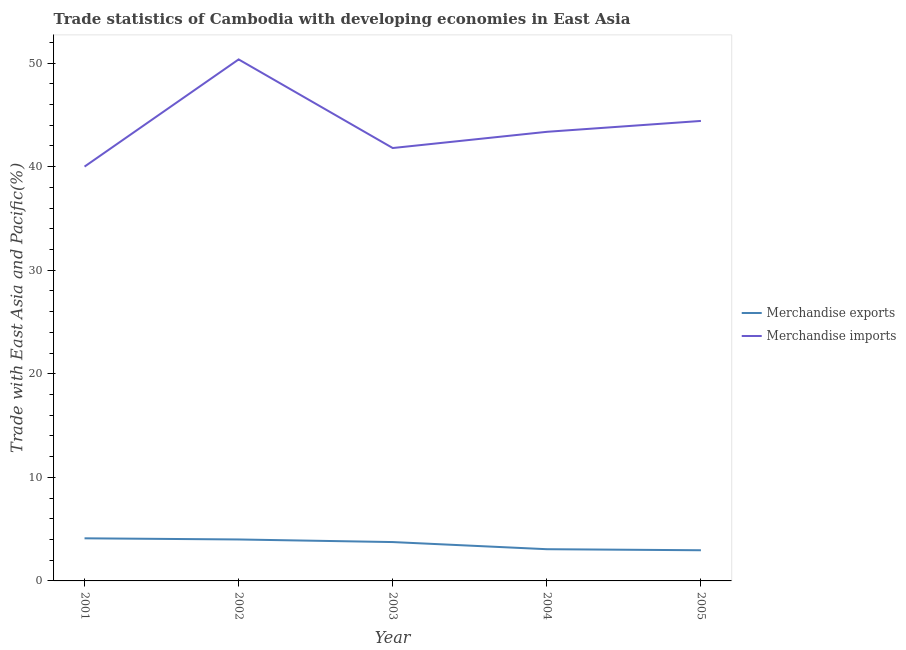How many different coloured lines are there?
Provide a succinct answer. 2. Does the line corresponding to merchandise imports intersect with the line corresponding to merchandise exports?
Ensure brevity in your answer.  No. What is the merchandise exports in 2004?
Provide a short and direct response. 3.06. Across all years, what is the maximum merchandise imports?
Ensure brevity in your answer.  50.36. Across all years, what is the minimum merchandise exports?
Your answer should be very brief. 2.96. In which year was the merchandise exports maximum?
Provide a short and direct response. 2001. In which year was the merchandise exports minimum?
Give a very brief answer. 2005. What is the total merchandise imports in the graph?
Provide a short and direct response. 219.94. What is the difference between the merchandise exports in 2001 and that in 2005?
Provide a short and direct response. 1.15. What is the difference between the merchandise exports in 2003 and the merchandise imports in 2004?
Your response must be concise. -39.61. What is the average merchandise exports per year?
Your response must be concise. 3.58. In the year 2001, what is the difference between the merchandise exports and merchandise imports?
Provide a short and direct response. -35.89. In how many years, is the merchandise exports greater than 46 %?
Offer a terse response. 0. What is the ratio of the merchandise imports in 2001 to that in 2002?
Give a very brief answer. 0.79. Is the difference between the merchandise exports in 2002 and 2003 greater than the difference between the merchandise imports in 2002 and 2003?
Ensure brevity in your answer.  No. What is the difference between the highest and the second highest merchandise imports?
Offer a very short reply. 5.94. What is the difference between the highest and the lowest merchandise imports?
Your response must be concise. 10.35. In how many years, is the merchandise exports greater than the average merchandise exports taken over all years?
Offer a terse response. 3. Does the merchandise imports monotonically increase over the years?
Make the answer very short. No. Is the merchandise exports strictly greater than the merchandise imports over the years?
Keep it short and to the point. No. How many years are there in the graph?
Your answer should be compact. 5. Are the values on the major ticks of Y-axis written in scientific E-notation?
Your answer should be very brief. No. How are the legend labels stacked?
Ensure brevity in your answer.  Vertical. What is the title of the graph?
Your response must be concise. Trade statistics of Cambodia with developing economies in East Asia. What is the label or title of the Y-axis?
Offer a terse response. Trade with East Asia and Pacific(%). What is the Trade with East Asia and Pacific(%) in Merchandise exports in 2001?
Make the answer very short. 4.11. What is the Trade with East Asia and Pacific(%) of Merchandise imports in 2001?
Provide a short and direct response. 40.01. What is the Trade with East Asia and Pacific(%) of Merchandise exports in 2002?
Give a very brief answer. 4. What is the Trade with East Asia and Pacific(%) of Merchandise imports in 2002?
Offer a very short reply. 50.36. What is the Trade with East Asia and Pacific(%) of Merchandise exports in 2003?
Offer a terse response. 3.75. What is the Trade with East Asia and Pacific(%) of Merchandise imports in 2003?
Ensure brevity in your answer.  41.8. What is the Trade with East Asia and Pacific(%) of Merchandise exports in 2004?
Make the answer very short. 3.06. What is the Trade with East Asia and Pacific(%) of Merchandise imports in 2004?
Give a very brief answer. 43.37. What is the Trade with East Asia and Pacific(%) of Merchandise exports in 2005?
Provide a short and direct response. 2.96. What is the Trade with East Asia and Pacific(%) in Merchandise imports in 2005?
Ensure brevity in your answer.  44.42. Across all years, what is the maximum Trade with East Asia and Pacific(%) in Merchandise exports?
Your answer should be compact. 4.11. Across all years, what is the maximum Trade with East Asia and Pacific(%) in Merchandise imports?
Give a very brief answer. 50.36. Across all years, what is the minimum Trade with East Asia and Pacific(%) in Merchandise exports?
Offer a terse response. 2.96. Across all years, what is the minimum Trade with East Asia and Pacific(%) of Merchandise imports?
Provide a succinct answer. 40.01. What is the total Trade with East Asia and Pacific(%) of Merchandise exports in the graph?
Your answer should be compact. 17.89. What is the total Trade with East Asia and Pacific(%) of Merchandise imports in the graph?
Your answer should be compact. 219.94. What is the difference between the Trade with East Asia and Pacific(%) of Merchandise exports in 2001 and that in 2002?
Make the answer very short. 0.11. What is the difference between the Trade with East Asia and Pacific(%) in Merchandise imports in 2001 and that in 2002?
Your answer should be compact. -10.35. What is the difference between the Trade with East Asia and Pacific(%) in Merchandise exports in 2001 and that in 2003?
Offer a terse response. 0.36. What is the difference between the Trade with East Asia and Pacific(%) in Merchandise imports in 2001 and that in 2003?
Offer a terse response. -1.79. What is the difference between the Trade with East Asia and Pacific(%) in Merchandise exports in 2001 and that in 2004?
Your response must be concise. 1.05. What is the difference between the Trade with East Asia and Pacific(%) of Merchandise imports in 2001 and that in 2004?
Offer a very short reply. -3.36. What is the difference between the Trade with East Asia and Pacific(%) of Merchandise exports in 2001 and that in 2005?
Make the answer very short. 1.15. What is the difference between the Trade with East Asia and Pacific(%) in Merchandise imports in 2001 and that in 2005?
Make the answer very short. -4.41. What is the difference between the Trade with East Asia and Pacific(%) in Merchandise exports in 2002 and that in 2003?
Provide a succinct answer. 0.25. What is the difference between the Trade with East Asia and Pacific(%) in Merchandise imports in 2002 and that in 2003?
Give a very brief answer. 8.56. What is the difference between the Trade with East Asia and Pacific(%) in Merchandise exports in 2002 and that in 2004?
Give a very brief answer. 0.94. What is the difference between the Trade with East Asia and Pacific(%) of Merchandise imports in 2002 and that in 2004?
Give a very brief answer. 6.99. What is the difference between the Trade with East Asia and Pacific(%) in Merchandise exports in 2002 and that in 2005?
Offer a terse response. 1.04. What is the difference between the Trade with East Asia and Pacific(%) in Merchandise imports in 2002 and that in 2005?
Ensure brevity in your answer.  5.94. What is the difference between the Trade with East Asia and Pacific(%) in Merchandise exports in 2003 and that in 2004?
Offer a terse response. 0.69. What is the difference between the Trade with East Asia and Pacific(%) of Merchandise imports in 2003 and that in 2004?
Give a very brief answer. -1.56. What is the difference between the Trade with East Asia and Pacific(%) of Merchandise exports in 2003 and that in 2005?
Keep it short and to the point. 0.79. What is the difference between the Trade with East Asia and Pacific(%) in Merchandise imports in 2003 and that in 2005?
Your answer should be very brief. -2.62. What is the difference between the Trade with East Asia and Pacific(%) of Merchandise exports in 2004 and that in 2005?
Your answer should be very brief. 0.1. What is the difference between the Trade with East Asia and Pacific(%) of Merchandise imports in 2004 and that in 2005?
Make the answer very short. -1.05. What is the difference between the Trade with East Asia and Pacific(%) in Merchandise exports in 2001 and the Trade with East Asia and Pacific(%) in Merchandise imports in 2002?
Provide a short and direct response. -46.24. What is the difference between the Trade with East Asia and Pacific(%) of Merchandise exports in 2001 and the Trade with East Asia and Pacific(%) of Merchandise imports in 2003?
Ensure brevity in your answer.  -37.69. What is the difference between the Trade with East Asia and Pacific(%) in Merchandise exports in 2001 and the Trade with East Asia and Pacific(%) in Merchandise imports in 2004?
Give a very brief answer. -39.25. What is the difference between the Trade with East Asia and Pacific(%) of Merchandise exports in 2001 and the Trade with East Asia and Pacific(%) of Merchandise imports in 2005?
Your answer should be compact. -40.3. What is the difference between the Trade with East Asia and Pacific(%) of Merchandise exports in 2002 and the Trade with East Asia and Pacific(%) of Merchandise imports in 2003?
Make the answer very short. -37.8. What is the difference between the Trade with East Asia and Pacific(%) in Merchandise exports in 2002 and the Trade with East Asia and Pacific(%) in Merchandise imports in 2004?
Ensure brevity in your answer.  -39.36. What is the difference between the Trade with East Asia and Pacific(%) of Merchandise exports in 2002 and the Trade with East Asia and Pacific(%) of Merchandise imports in 2005?
Keep it short and to the point. -40.41. What is the difference between the Trade with East Asia and Pacific(%) in Merchandise exports in 2003 and the Trade with East Asia and Pacific(%) in Merchandise imports in 2004?
Offer a very short reply. -39.61. What is the difference between the Trade with East Asia and Pacific(%) in Merchandise exports in 2003 and the Trade with East Asia and Pacific(%) in Merchandise imports in 2005?
Your answer should be compact. -40.66. What is the difference between the Trade with East Asia and Pacific(%) of Merchandise exports in 2004 and the Trade with East Asia and Pacific(%) of Merchandise imports in 2005?
Ensure brevity in your answer.  -41.35. What is the average Trade with East Asia and Pacific(%) in Merchandise exports per year?
Ensure brevity in your answer.  3.58. What is the average Trade with East Asia and Pacific(%) in Merchandise imports per year?
Provide a succinct answer. 43.99. In the year 2001, what is the difference between the Trade with East Asia and Pacific(%) of Merchandise exports and Trade with East Asia and Pacific(%) of Merchandise imports?
Your response must be concise. -35.89. In the year 2002, what is the difference between the Trade with East Asia and Pacific(%) of Merchandise exports and Trade with East Asia and Pacific(%) of Merchandise imports?
Keep it short and to the point. -46.35. In the year 2003, what is the difference between the Trade with East Asia and Pacific(%) in Merchandise exports and Trade with East Asia and Pacific(%) in Merchandise imports?
Your response must be concise. -38.05. In the year 2004, what is the difference between the Trade with East Asia and Pacific(%) of Merchandise exports and Trade with East Asia and Pacific(%) of Merchandise imports?
Offer a very short reply. -40.3. In the year 2005, what is the difference between the Trade with East Asia and Pacific(%) in Merchandise exports and Trade with East Asia and Pacific(%) in Merchandise imports?
Keep it short and to the point. -41.45. What is the ratio of the Trade with East Asia and Pacific(%) of Merchandise exports in 2001 to that in 2002?
Make the answer very short. 1.03. What is the ratio of the Trade with East Asia and Pacific(%) of Merchandise imports in 2001 to that in 2002?
Your answer should be compact. 0.79. What is the ratio of the Trade with East Asia and Pacific(%) in Merchandise exports in 2001 to that in 2003?
Keep it short and to the point. 1.1. What is the ratio of the Trade with East Asia and Pacific(%) in Merchandise imports in 2001 to that in 2003?
Provide a succinct answer. 0.96. What is the ratio of the Trade with East Asia and Pacific(%) of Merchandise exports in 2001 to that in 2004?
Your answer should be compact. 1.34. What is the ratio of the Trade with East Asia and Pacific(%) in Merchandise imports in 2001 to that in 2004?
Your answer should be compact. 0.92. What is the ratio of the Trade with East Asia and Pacific(%) of Merchandise exports in 2001 to that in 2005?
Offer a terse response. 1.39. What is the ratio of the Trade with East Asia and Pacific(%) in Merchandise imports in 2001 to that in 2005?
Offer a terse response. 0.9. What is the ratio of the Trade with East Asia and Pacific(%) of Merchandise exports in 2002 to that in 2003?
Your response must be concise. 1.07. What is the ratio of the Trade with East Asia and Pacific(%) in Merchandise imports in 2002 to that in 2003?
Your response must be concise. 1.2. What is the ratio of the Trade with East Asia and Pacific(%) in Merchandise exports in 2002 to that in 2004?
Offer a terse response. 1.31. What is the ratio of the Trade with East Asia and Pacific(%) of Merchandise imports in 2002 to that in 2004?
Give a very brief answer. 1.16. What is the ratio of the Trade with East Asia and Pacific(%) of Merchandise exports in 2002 to that in 2005?
Provide a short and direct response. 1.35. What is the ratio of the Trade with East Asia and Pacific(%) of Merchandise imports in 2002 to that in 2005?
Your answer should be very brief. 1.13. What is the ratio of the Trade with East Asia and Pacific(%) of Merchandise exports in 2003 to that in 2004?
Make the answer very short. 1.22. What is the ratio of the Trade with East Asia and Pacific(%) in Merchandise imports in 2003 to that in 2004?
Give a very brief answer. 0.96. What is the ratio of the Trade with East Asia and Pacific(%) in Merchandise exports in 2003 to that in 2005?
Give a very brief answer. 1.27. What is the ratio of the Trade with East Asia and Pacific(%) in Merchandise imports in 2003 to that in 2005?
Your answer should be very brief. 0.94. What is the ratio of the Trade with East Asia and Pacific(%) of Merchandise exports in 2004 to that in 2005?
Your response must be concise. 1.03. What is the ratio of the Trade with East Asia and Pacific(%) of Merchandise imports in 2004 to that in 2005?
Give a very brief answer. 0.98. What is the difference between the highest and the second highest Trade with East Asia and Pacific(%) of Merchandise exports?
Your response must be concise. 0.11. What is the difference between the highest and the second highest Trade with East Asia and Pacific(%) in Merchandise imports?
Your answer should be very brief. 5.94. What is the difference between the highest and the lowest Trade with East Asia and Pacific(%) in Merchandise exports?
Your answer should be compact. 1.15. What is the difference between the highest and the lowest Trade with East Asia and Pacific(%) of Merchandise imports?
Offer a very short reply. 10.35. 